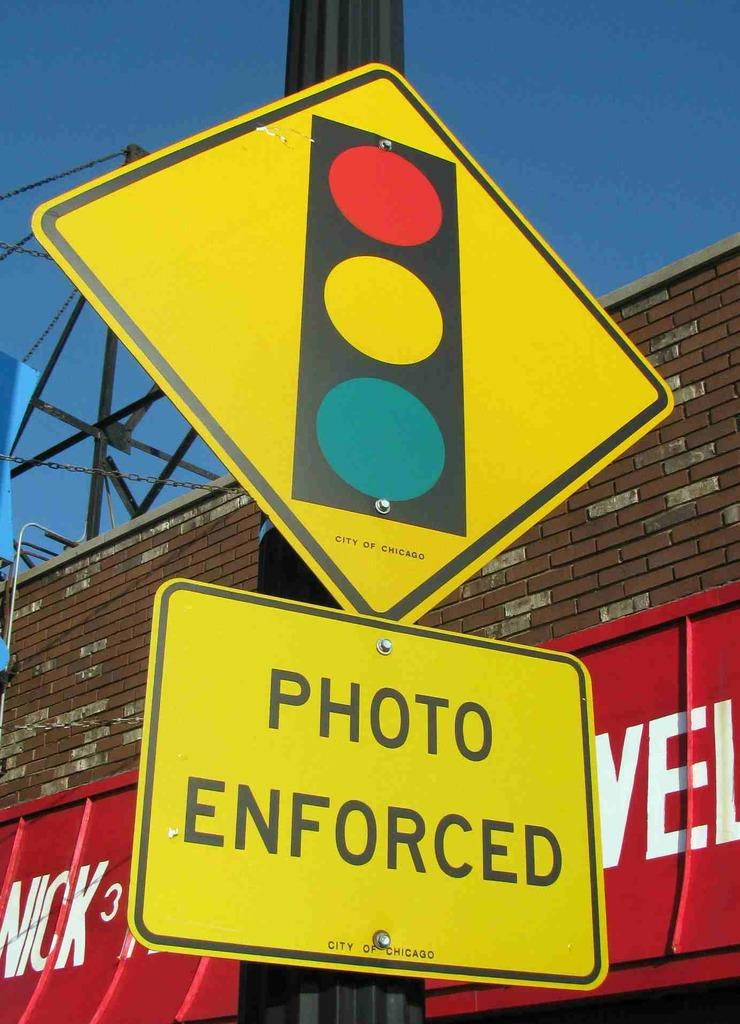Provide a one-sentence caption for the provided image. yellow street sign with the words photo enforced. 